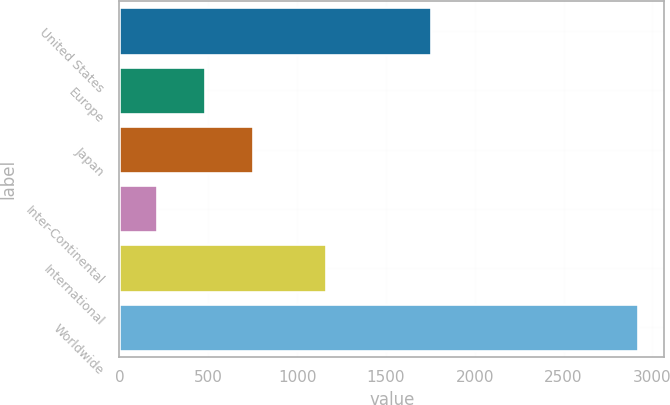Convert chart. <chart><loc_0><loc_0><loc_500><loc_500><bar_chart><fcel>United States<fcel>Europe<fcel>Japan<fcel>Inter-Continental<fcel>International<fcel>Worldwide<nl><fcel>1756<fcel>483.6<fcel>754.2<fcel>213<fcel>1163<fcel>2919<nl></chart> 